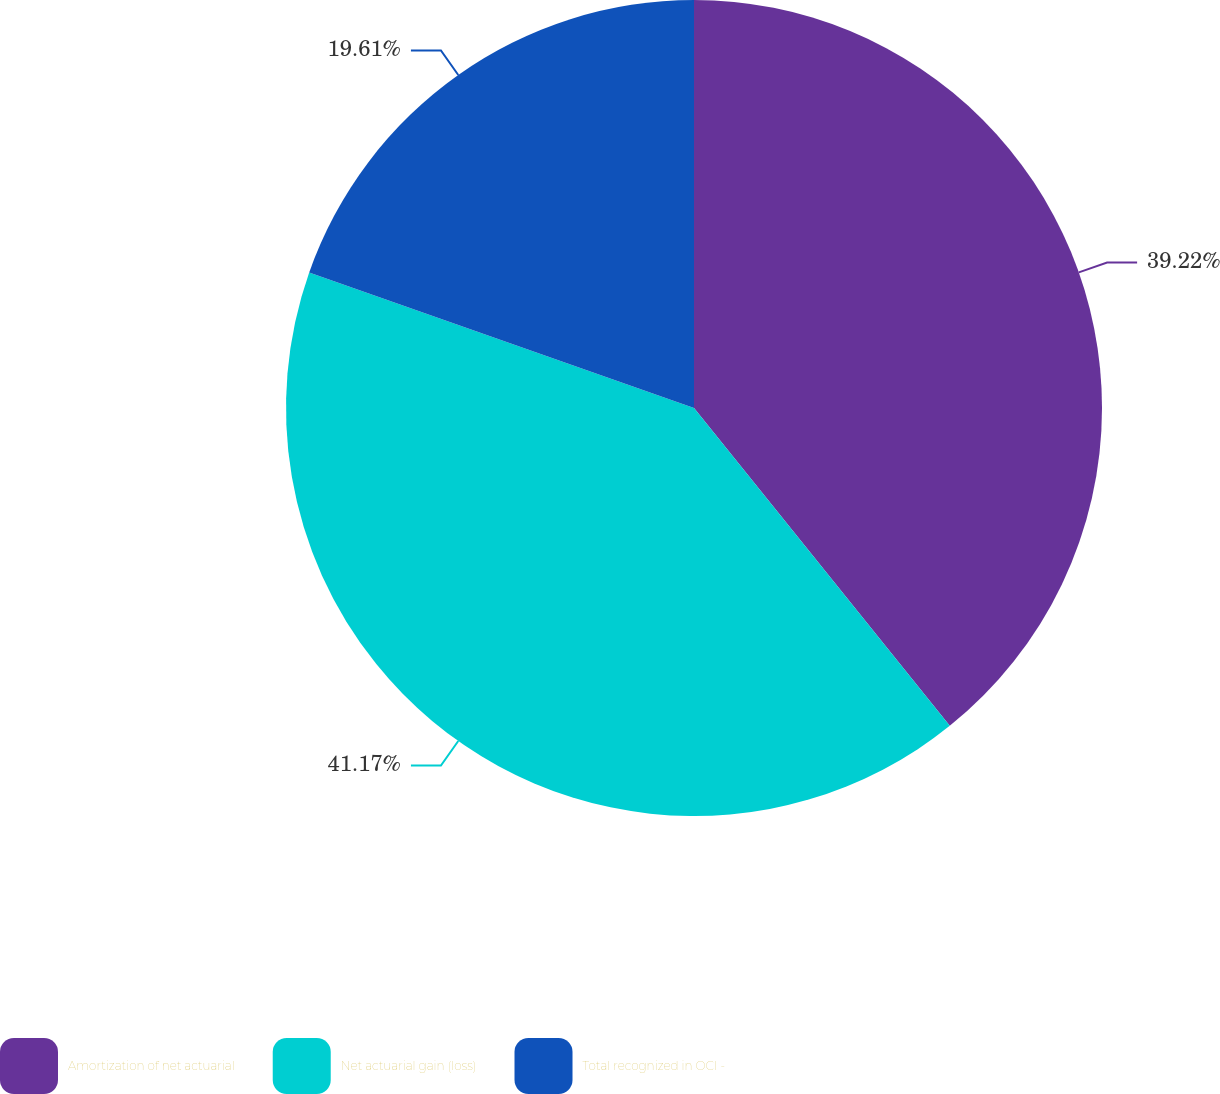<chart> <loc_0><loc_0><loc_500><loc_500><pie_chart><fcel>Amortization of net actuarial<fcel>Net actuarial gain (loss)<fcel>Total recognized in OCI -<nl><fcel>39.22%<fcel>41.18%<fcel>19.61%<nl></chart> 